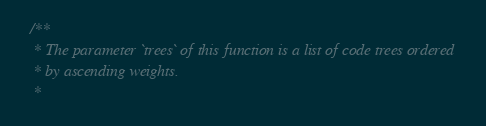<code> <loc_0><loc_0><loc_500><loc_500><_Scala_>  /**
   * The parameter `trees` of this function is a list of code trees ordered
   * by ascending weights.
   *</code> 